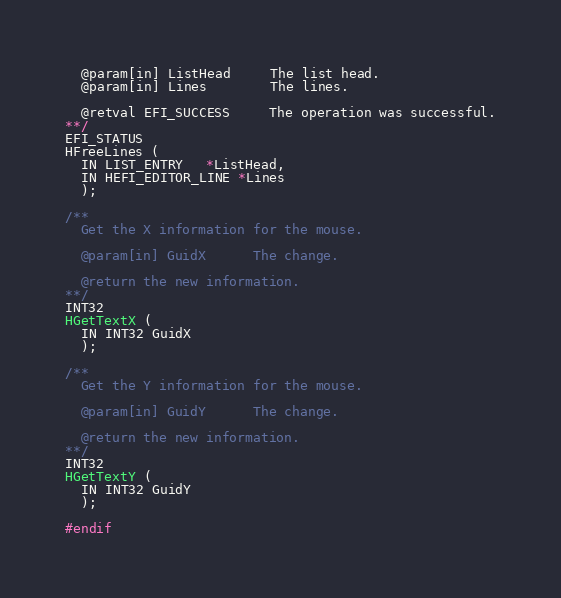<code> <loc_0><loc_0><loc_500><loc_500><_C_>  @param[in] ListHead     The list head.
  @param[in] Lines        The lines.

  @retval EFI_SUCCESS     The operation was successful.
**/
EFI_STATUS
HFreeLines (
  IN LIST_ENTRY   *ListHead,
  IN HEFI_EDITOR_LINE *Lines
  );

/**
  Get the X information for the mouse.

  @param[in] GuidX      The change.

  @return the new information.
**/
INT32
HGetTextX (
  IN INT32 GuidX
  );

/**
  Get the Y information for the mouse.

  @param[in] GuidY      The change.

  @return the new information.
**/
INT32
HGetTextY (
  IN INT32 GuidY
  );

#endif
</code> 